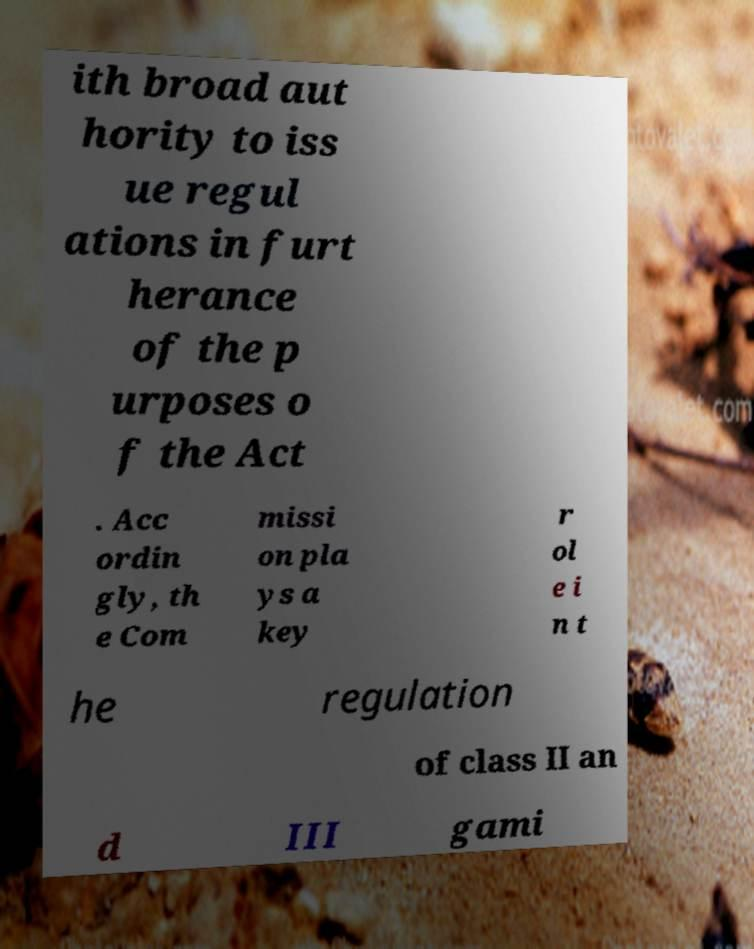There's text embedded in this image that I need extracted. Can you transcribe it verbatim? ith broad aut hority to iss ue regul ations in furt herance of the p urposes o f the Act . Acc ordin gly, th e Com missi on pla ys a key r ol e i n t he regulation of class II an d III gami 